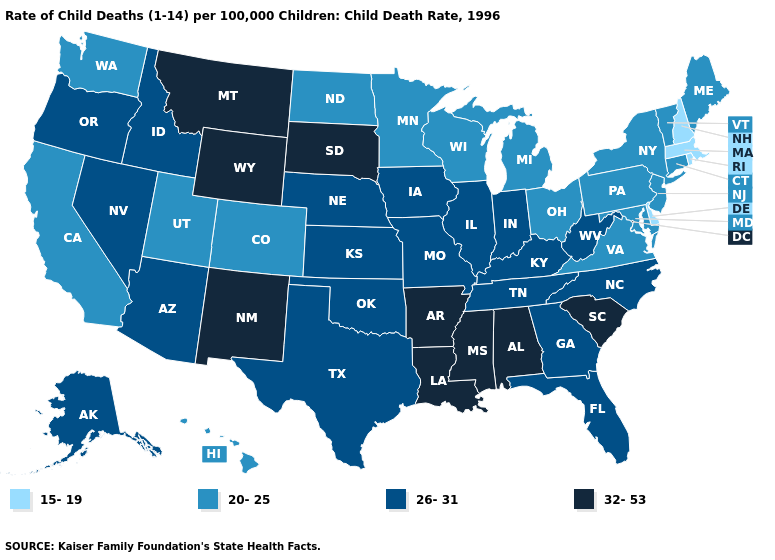Name the states that have a value in the range 20-25?
Answer briefly. California, Colorado, Connecticut, Hawaii, Maine, Maryland, Michigan, Minnesota, New Jersey, New York, North Dakota, Ohio, Pennsylvania, Utah, Vermont, Virginia, Washington, Wisconsin. Does Kentucky have the highest value in the USA?
Quick response, please. No. Does the map have missing data?
Short answer required. No. Is the legend a continuous bar?
Concise answer only. No. Name the states that have a value in the range 32-53?
Concise answer only. Alabama, Arkansas, Louisiana, Mississippi, Montana, New Mexico, South Carolina, South Dakota, Wyoming. What is the value of Texas?
Short answer required. 26-31. What is the value of Rhode Island?
Be succinct. 15-19. Among the states that border Oregon , does Washington have the lowest value?
Short answer required. Yes. Does Connecticut have the highest value in the Northeast?
Keep it brief. Yes. Name the states that have a value in the range 32-53?
Write a very short answer. Alabama, Arkansas, Louisiana, Mississippi, Montana, New Mexico, South Carolina, South Dakota, Wyoming. Name the states that have a value in the range 26-31?
Concise answer only. Alaska, Arizona, Florida, Georgia, Idaho, Illinois, Indiana, Iowa, Kansas, Kentucky, Missouri, Nebraska, Nevada, North Carolina, Oklahoma, Oregon, Tennessee, Texas, West Virginia. Which states have the highest value in the USA?
Be succinct. Alabama, Arkansas, Louisiana, Mississippi, Montana, New Mexico, South Carolina, South Dakota, Wyoming. Is the legend a continuous bar?
Concise answer only. No. Name the states that have a value in the range 20-25?
Short answer required. California, Colorado, Connecticut, Hawaii, Maine, Maryland, Michigan, Minnesota, New Jersey, New York, North Dakota, Ohio, Pennsylvania, Utah, Vermont, Virginia, Washington, Wisconsin. Does Oregon have a higher value than Michigan?
Quick response, please. Yes. 